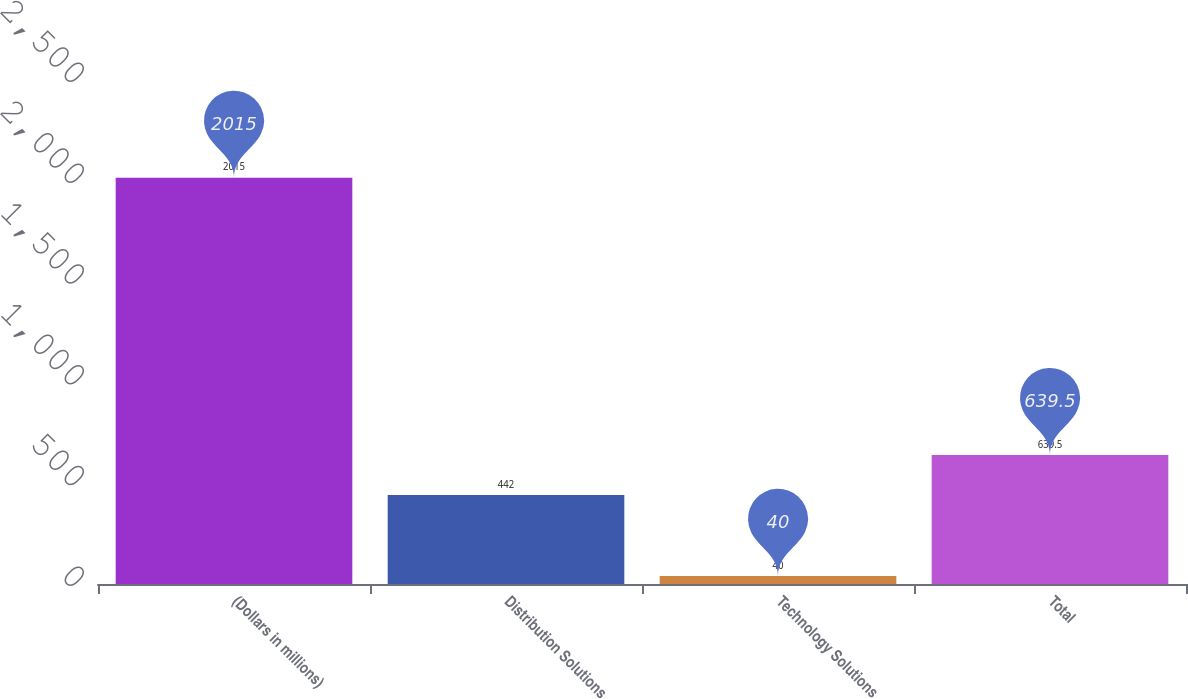Convert chart to OTSL. <chart><loc_0><loc_0><loc_500><loc_500><bar_chart><fcel>(Dollars in millions)<fcel>Distribution Solutions<fcel>Technology Solutions<fcel>Total<nl><fcel>2015<fcel>442<fcel>40<fcel>639.5<nl></chart> 